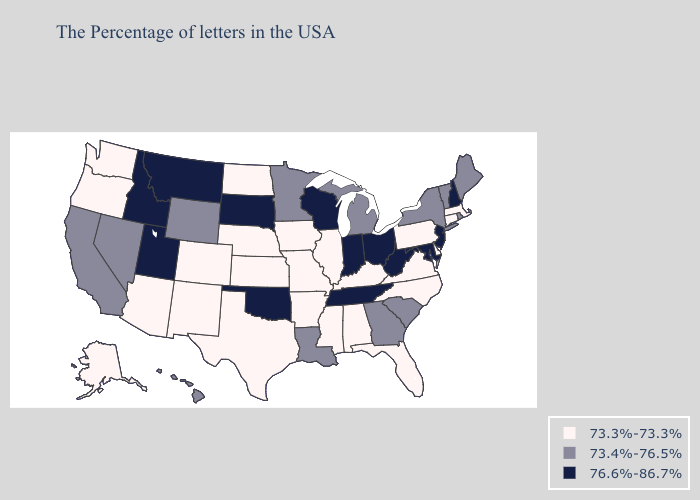Name the states that have a value in the range 76.6%-86.7%?
Keep it brief. New Hampshire, New Jersey, Maryland, West Virginia, Ohio, Indiana, Tennessee, Wisconsin, Oklahoma, South Dakota, Utah, Montana, Idaho. Name the states that have a value in the range 73.4%-76.5%?
Answer briefly. Maine, Rhode Island, Vermont, New York, South Carolina, Georgia, Michigan, Louisiana, Minnesota, Wyoming, Nevada, California, Hawaii. What is the lowest value in states that border Arizona?
Answer briefly. 73.3%-73.3%. Does Alaska have the highest value in the USA?
Be succinct. No. Name the states that have a value in the range 76.6%-86.7%?
Concise answer only. New Hampshire, New Jersey, Maryland, West Virginia, Ohio, Indiana, Tennessee, Wisconsin, Oklahoma, South Dakota, Utah, Montana, Idaho. Name the states that have a value in the range 73.4%-76.5%?
Be succinct. Maine, Rhode Island, Vermont, New York, South Carolina, Georgia, Michigan, Louisiana, Minnesota, Wyoming, Nevada, California, Hawaii. Does the first symbol in the legend represent the smallest category?
Write a very short answer. Yes. Which states hav the highest value in the Northeast?
Answer briefly. New Hampshire, New Jersey. Name the states that have a value in the range 73.3%-73.3%?
Give a very brief answer. Massachusetts, Connecticut, Delaware, Pennsylvania, Virginia, North Carolina, Florida, Kentucky, Alabama, Illinois, Mississippi, Missouri, Arkansas, Iowa, Kansas, Nebraska, Texas, North Dakota, Colorado, New Mexico, Arizona, Washington, Oregon, Alaska. Which states have the lowest value in the USA?
Be succinct. Massachusetts, Connecticut, Delaware, Pennsylvania, Virginia, North Carolina, Florida, Kentucky, Alabama, Illinois, Mississippi, Missouri, Arkansas, Iowa, Kansas, Nebraska, Texas, North Dakota, Colorado, New Mexico, Arizona, Washington, Oregon, Alaska. Is the legend a continuous bar?
Quick response, please. No. Name the states that have a value in the range 73.3%-73.3%?
Give a very brief answer. Massachusetts, Connecticut, Delaware, Pennsylvania, Virginia, North Carolina, Florida, Kentucky, Alabama, Illinois, Mississippi, Missouri, Arkansas, Iowa, Kansas, Nebraska, Texas, North Dakota, Colorado, New Mexico, Arizona, Washington, Oregon, Alaska. Among the states that border Rhode Island , which have the highest value?
Short answer required. Massachusetts, Connecticut. Is the legend a continuous bar?
Keep it brief. No. Does Indiana have the same value as Montana?
Quick response, please. Yes. 